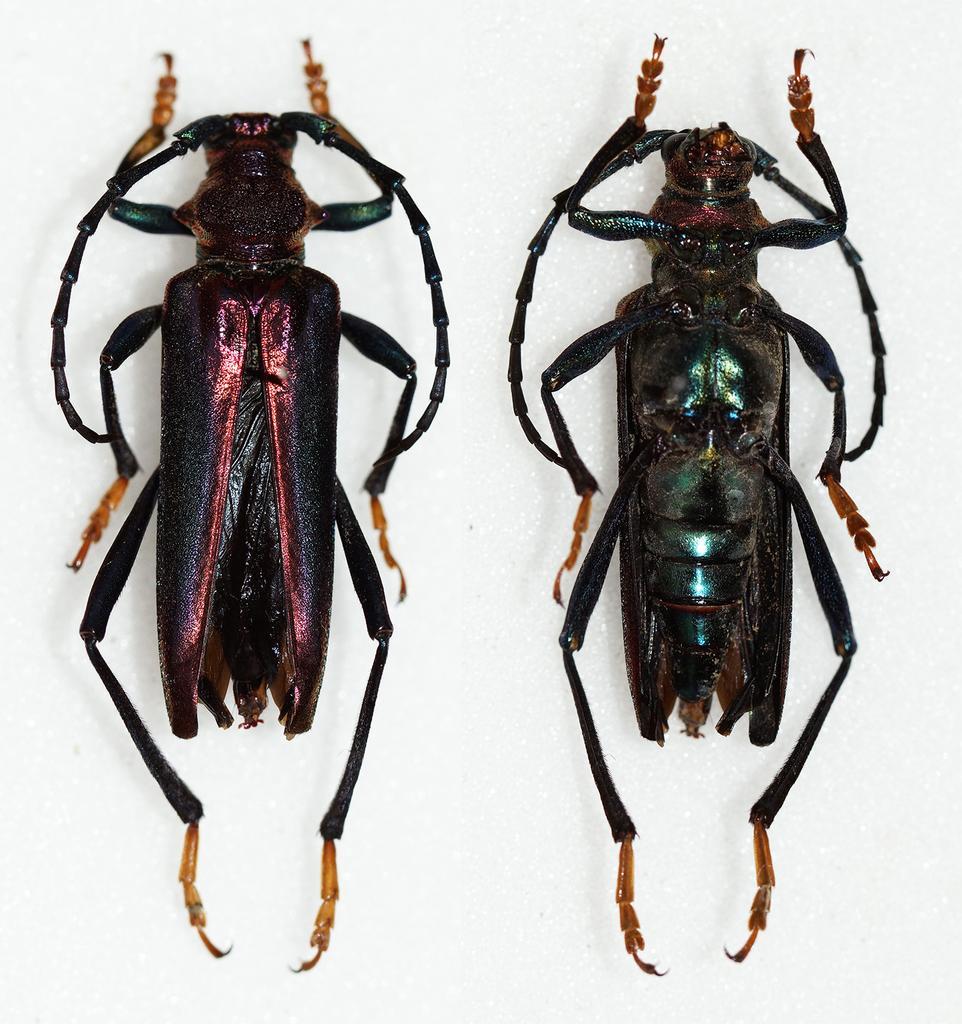How would you summarize this image in a sentence or two? In this image we can see two insects on the white color surface. 